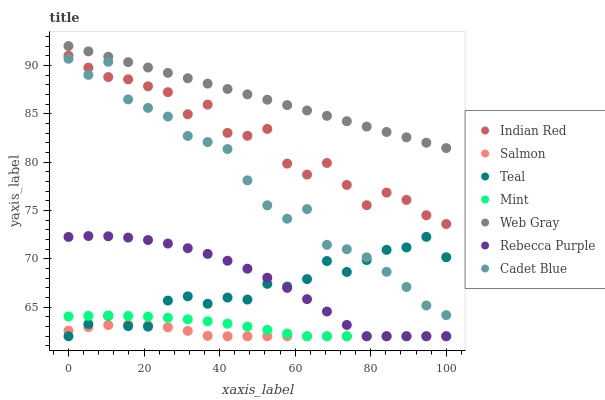Does Salmon have the minimum area under the curve?
Answer yes or no. Yes. Does Web Gray have the maximum area under the curve?
Answer yes or no. Yes. Does Indian Red have the minimum area under the curve?
Answer yes or no. No. Does Indian Red have the maximum area under the curve?
Answer yes or no. No. Is Web Gray the smoothest?
Answer yes or no. Yes. Is Indian Red the roughest?
Answer yes or no. Yes. Is Salmon the smoothest?
Answer yes or no. No. Is Salmon the roughest?
Answer yes or no. No. Does Salmon have the lowest value?
Answer yes or no. Yes. Does Indian Red have the lowest value?
Answer yes or no. No. Does Web Gray have the highest value?
Answer yes or no. Yes. Does Indian Red have the highest value?
Answer yes or no. No. Is Rebecca Purple less than Cadet Blue?
Answer yes or no. Yes. Is Web Gray greater than Salmon?
Answer yes or no. Yes. Does Rebecca Purple intersect Salmon?
Answer yes or no. Yes. Is Rebecca Purple less than Salmon?
Answer yes or no. No. Is Rebecca Purple greater than Salmon?
Answer yes or no. No. Does Rebecca Purple intersect Cadet Blue?
Answer yes or no. No. 